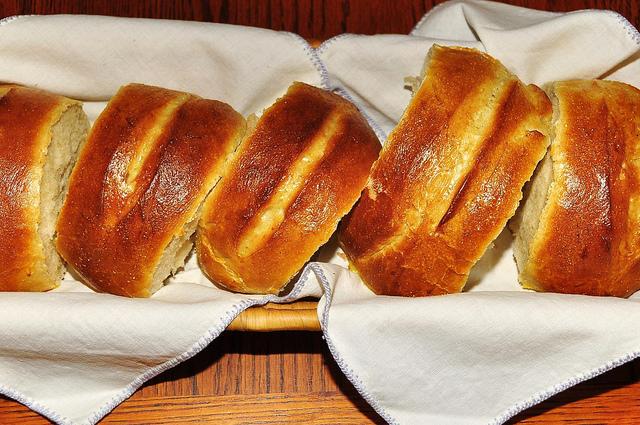What is under the bread?
Concise answer only. Napkin. How many pieces of bread are there?
Write a very short answer. 5. Can someone on a no-carb diet eat these?
Quick response, please. No. 